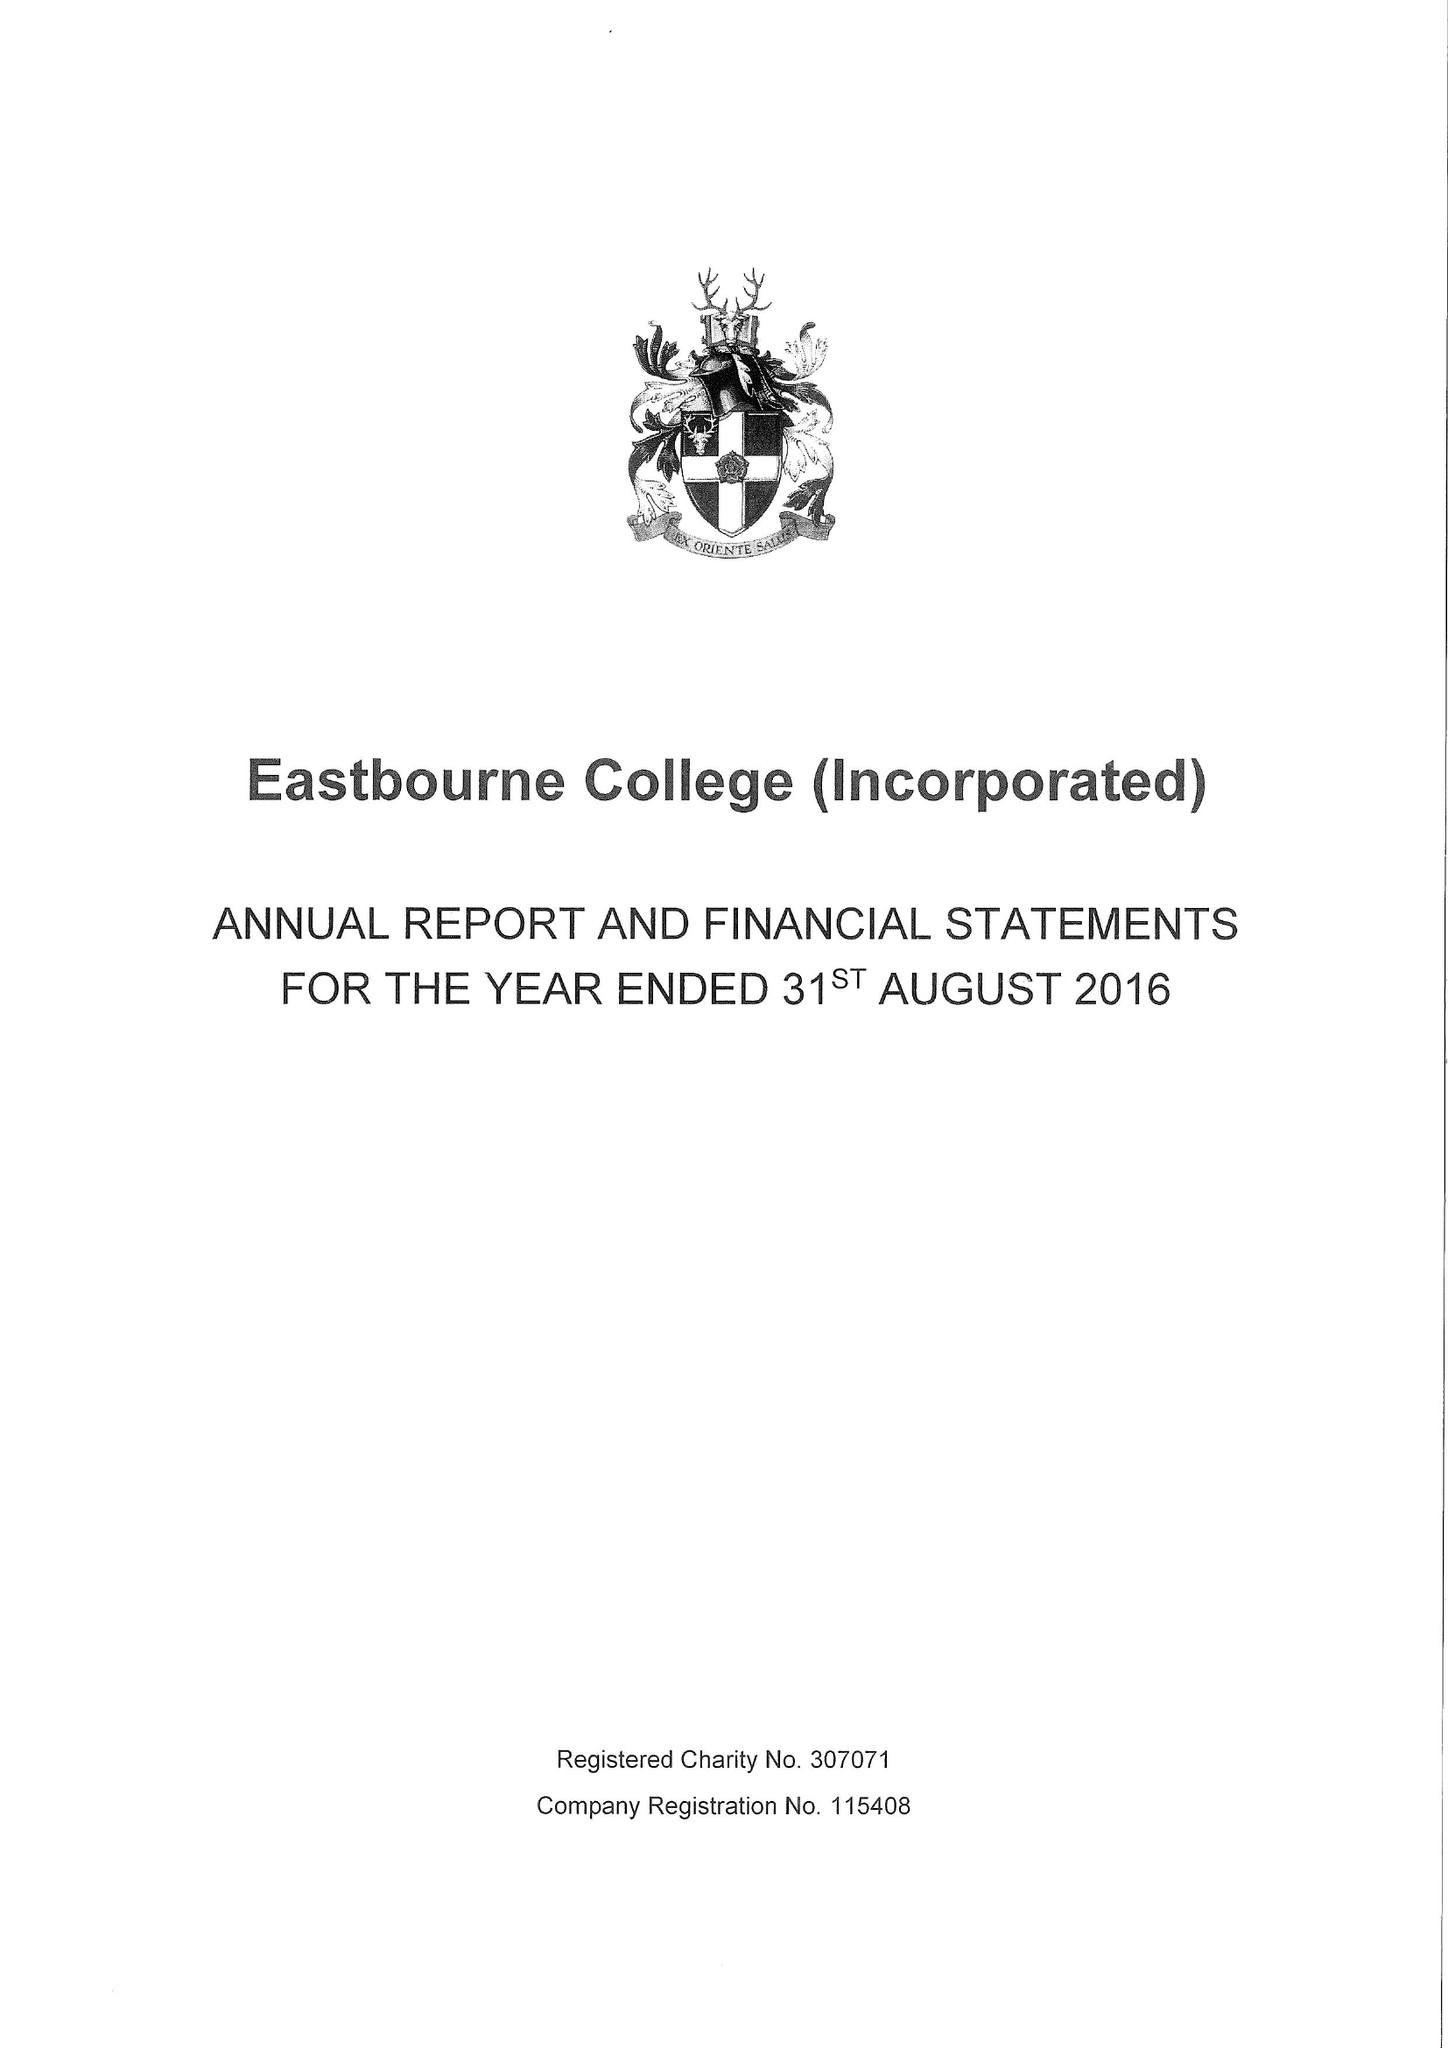What is the value for the address__street_line?
Answer the question using a single word or phrase. OLD WISH ROAD 